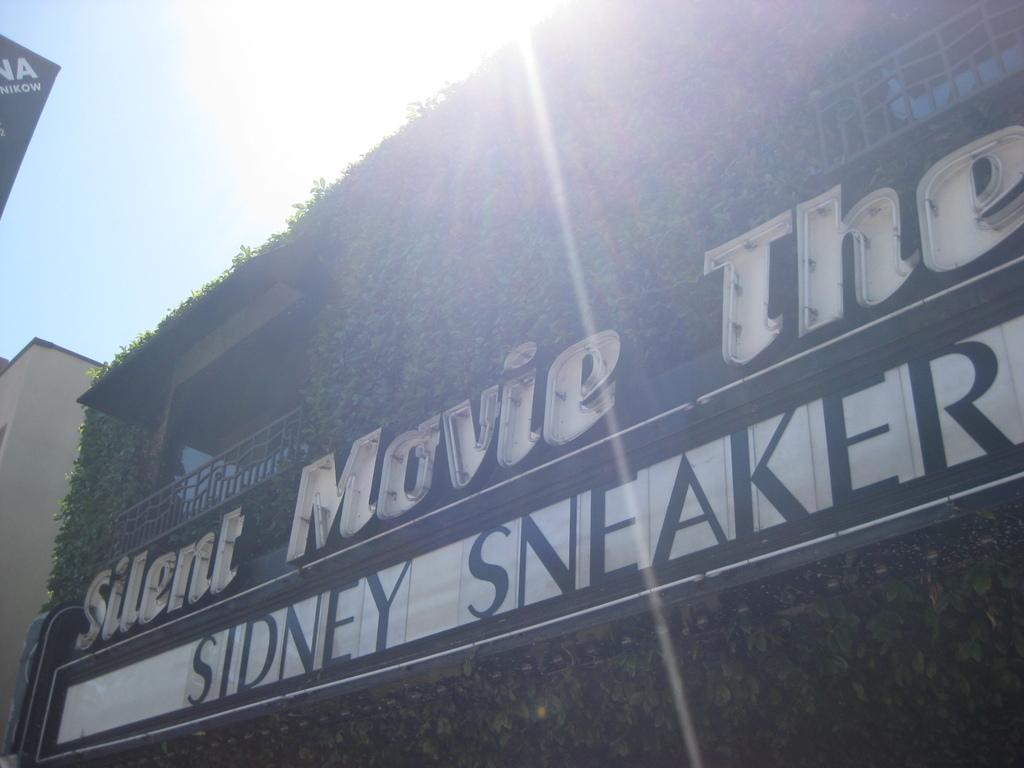<image>
Give a short and clear explanation of the subsequent image. Sidney Sneaker plays at a silent movie theatre. 